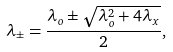Convert formula to latex. <formula><loc_0><loc_0><loc_500><loc_500>\lambda _ { \pm } = \frac { \lambda _ { o } \pm \sqrt { \lambda _ { o } ^ { 2 } + 4 \lambda _ { x } } } { 2 } ,</formula> 